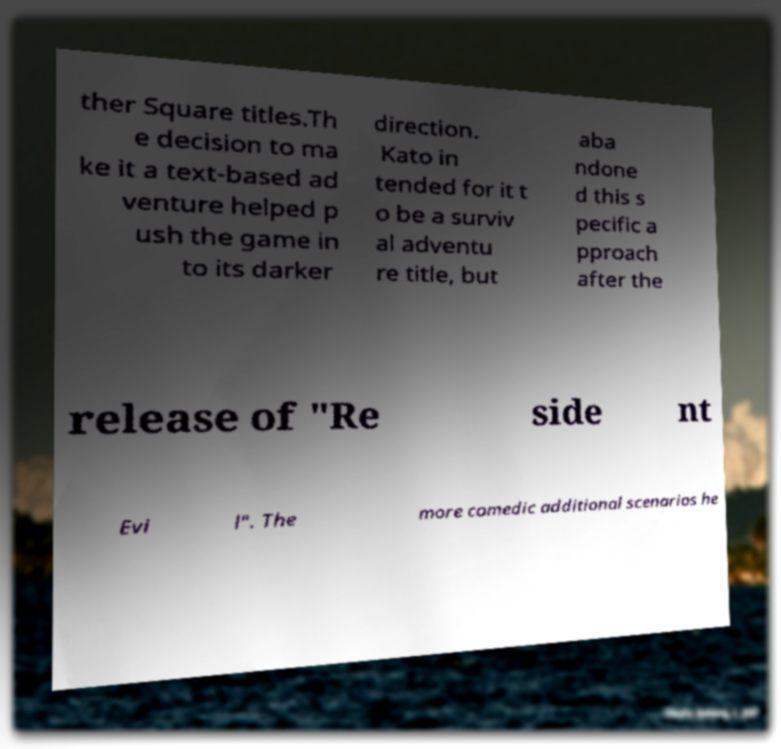Can you accurately transcribe the text from the provided image for me? ther Square titles.Th e decision to ma ke it a text-based ad venture helped p ush the game in to its darker direction. Kato in tended for it t o be a surviv al adventu re title, but aba ndone d this s pecific a pproach after the release of "Re side nt Evi l". The more comedic additional scenarios he 